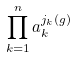<formula> <loc_0><loc_0><loc_500><loc_500>\prod _ { k = 1 } ^ { n } a _ { k } ^ { j _ { k } ( g ) }</formula> 